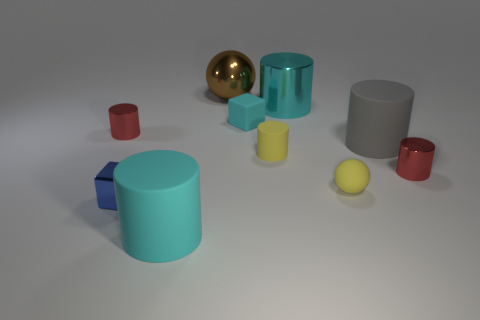What number of metallic things are either cyan things or large cylinders?
Keep it short and to the point. 1. How many shiny objects are the same color as the tiny metal cube?
Offer a terse response. 0. The block behind the red metallic cylinder that is on the right side of the small shiny cylinder on the left side of the big cyan rubber cylinder is made of what material?
Your answer should be compact. Rubber. What color is the sphere that is behind the large matte cylinder behind the metal cube?
Your answer should be very brief. Brown. How many large things are yellow cylinders or matte cylinders?
Give a very brief answer. 2. What number of large cubes are the same material as the gray object?
Make the answer very short. 0. What is the size of the sphere that is on the left side of the yellow matte ball?
Provide a succinct answer. Large. The matte thing that is behind the red metal object that is on the left side of the brown shiny thing is what shape?
Offer a terse response. Cube. How many cyan objects are in front of the red metal cylinder that is in front of the red shiny thing on the left side of the metallic ball?
Your response must be concise. 1. Is the number of tiny cylinders that are to the right of the small cyan block less than the number of matte cylinders?
Your answer should be very brief. Yes. 